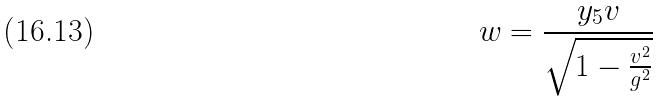Convert formula to latex. <formula><loc_0><loc_0><loc_500><loc_500>w = \frac { y _ { 5 } v } { \sqrt { 1 - \frac { v ^ { 2 } } { g ^ { 2 } } } }</formula> 